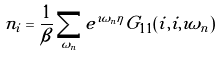Convert formula to latex. <formula><loc_0><loc_0><loc_500><loc_500>n _ { i } = \frac { 1 } { \beta } \sum _ { \omega _ { n } } e ^ { \imath \omega _ { n } \eta } G _ { 1 1 } ( i , i , \imath \omega _ { n } )</formula> 